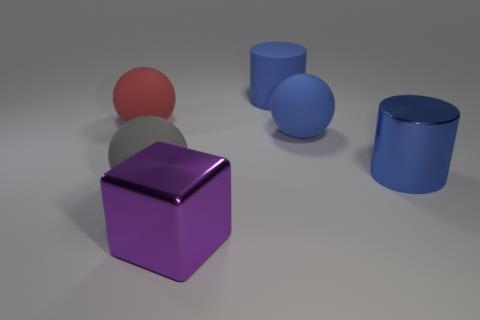Add 3 balls. How many objects exist? 9 Subtract all blocks. How many objects are left? 5 Add 4 large red objects. How many large red objects are left? 5 Add 1 red matte things. How many red matte things exist? 2 Subtract 1 red spheres. How many objects are left? 5 Subtract all gray matte spheres. Subtract all red matte balls. How many objects are left? 4 